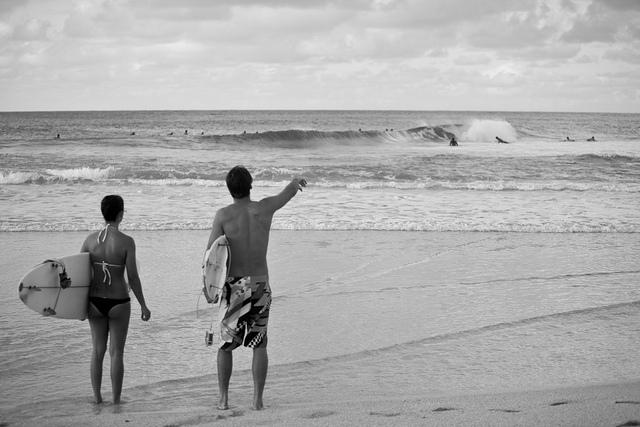What is the thing at the bottom of her surfboard?
Write a very short answer. Leash. Where was this picture taken?
Concise answer only. Beach. What is the man pointing at?
Give a very brief answer. Waves. What are they holding?
Answer briefly. Surfboards. Are they carrying the boards with the same hands?
Short answer required. Yes. 